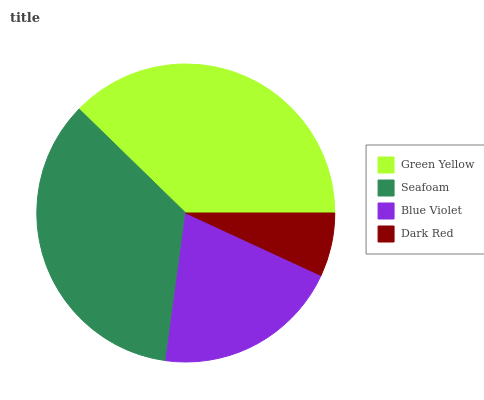Is Dark Red the minimum?
Answer yes or no. Yes. Is Green Yellow the maximum?
Answer yes or no. Yes. Is Seafoam the minimum?
Answer yes or no. No. Is Seafoam the maximum?
Answer yes or no. No. Is Green Yellow greater than Seafoam?
Answer yes or no. Yes. Is Seafoam less than Green Yellow?
Answer yes or no. Yes. Is Seafoam greater than Green Yellow?
Answer yes or no. No. Is Green Yellow less than Seafoam?
Answer yes or no. No. Is Seafoam the high median?
Answer yes or no. Yes. Is Blue Violet the low median?
Answer yes or no. Yes. Is Dark Red the high median?
Answer yes or no. No. Is Seafoam the low median?
Answer yes or no. No. 